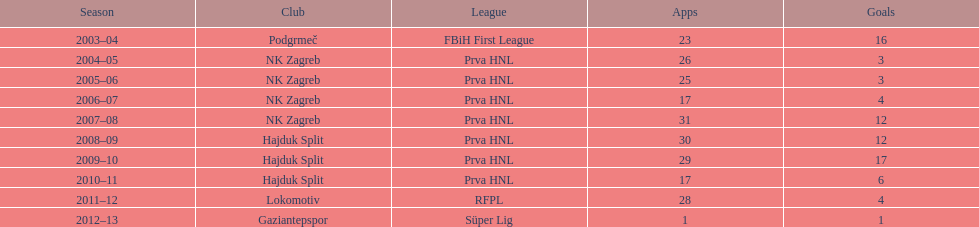Was ibricic's goal count higher or lower in his 3 seasons with hajduk split in comparison to his 4 seasons with nk zagreb? More. 